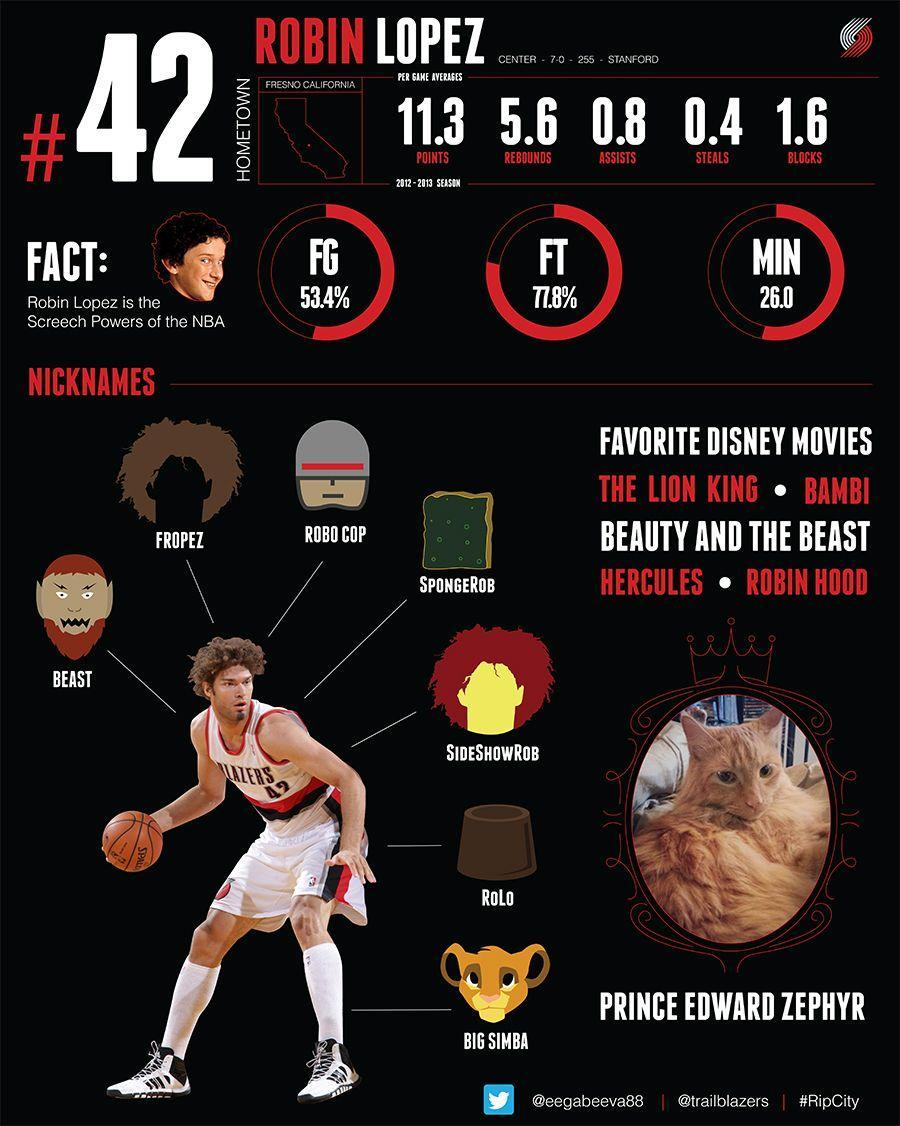How many favourite movies has been listed
Answer the question with a short phrase. 5 What is the name of the cat Prince Edward Zephyr Where is the hometown of Robin Lopez Fresno California How many nicknames does RObin Lopez have 7 7 What is the nickname with the lion head Big Simba 